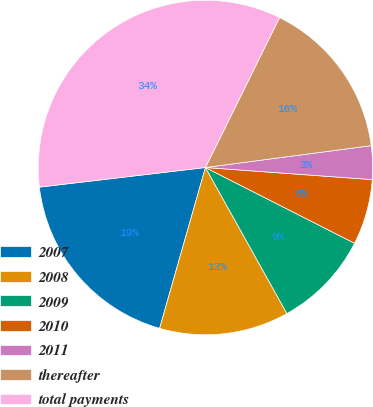<chart> <loc_0><loc_0><loc_500><loc_500><pie_chart><fcel>2007<fcel>2008<fcel>2009<fcel>2010<fcel>2011<fcel>thereafter<fcel>total payments<nl><fcel>18.71%<fcel>12.52%<fcel>9.42%<fcel>6.33%<fcel>3.24%<fcel>15.61%<fcel>34.18%<nl></chart> 